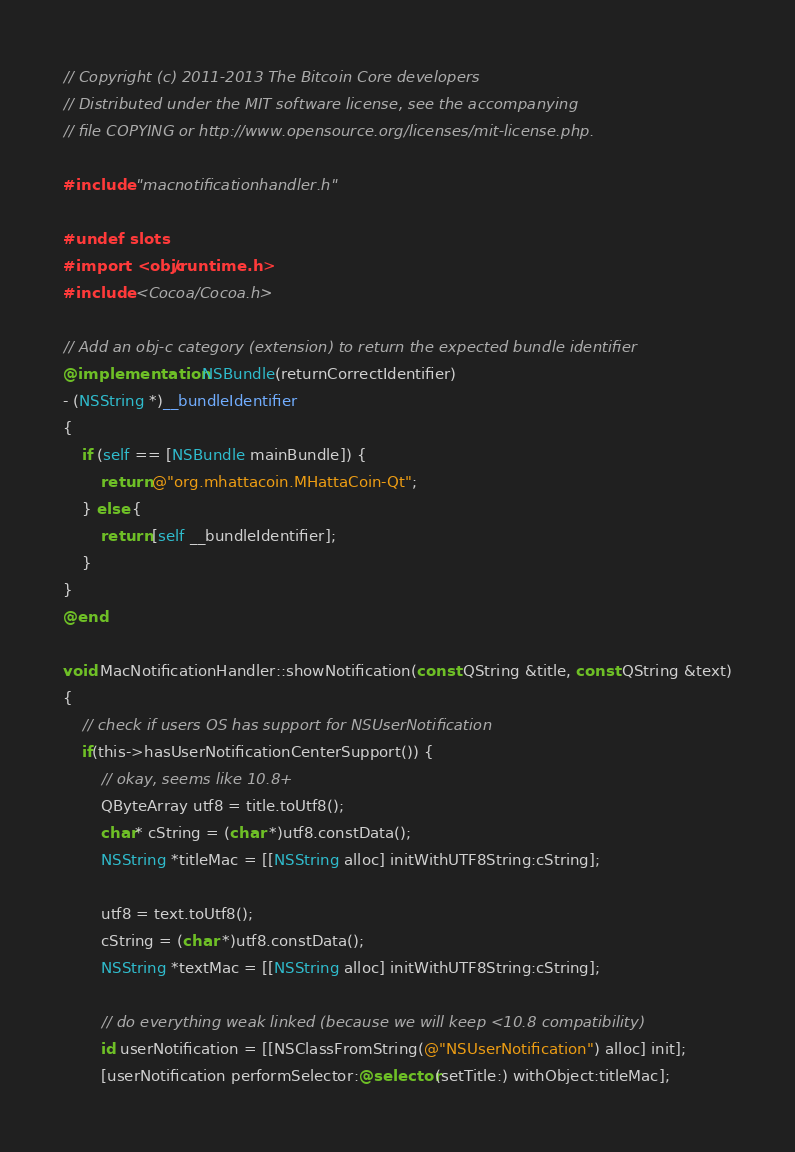Convert code to text. <code><loc_0><loc_0><loc_500><loc_500><_ObjectiveC_>// Copyright (c) 2011-2013 The Bitcoin Core developers
// Distributed under the MIT software license, see the accompanying
// file COPYING or http://www.opensource.org/licenses/mit-license.php.

#include "macnotificationhandler.h"

#undef slots
#import <objc/runtime.h>
#include <Cocoa/Cocoa.h>

// Add an obj-c category (extension) to return the expected bundle identifier
@implementation NSBundle(returnCorrectIdentifier)
- (NSString *)__bundleIdentifier
{
    if (self == [NSBundle mainBundle]) {
        return @"org.mhattacoin.MHattaCoin-Qt";
    } else {
        return [self __bundleIdentifier];
    }
}
@end

void MacNotificationHandler::showNotification(const QString &title, const QString &text)
{
    // check if users OS has support for NSUserNotification
    if(this->hasUserNotificationCenterSupport()) {
        // okay, seems like 10.8+
        QByteArray utf8 = title.toUtf8();
        char* cString = (char *)utf8.constData();
        NSString *titleMac = [[NSString alloc] initWithUTF8String:cString];

        utf8 = text.toUtf8();
        cString = (char *)utf8.constData();
        NSString *textMac = [[NSString alloc] initWithUTF8String:cString];

        // do everything weak linked (because we will keep <10.8 compatibility)
        id userNotification = [[NSClassFromString(@"NSUserNotification") alloc] init];
        [userNotification performSelector:@selector(setTitle:) withObject:titleMac];</code> 